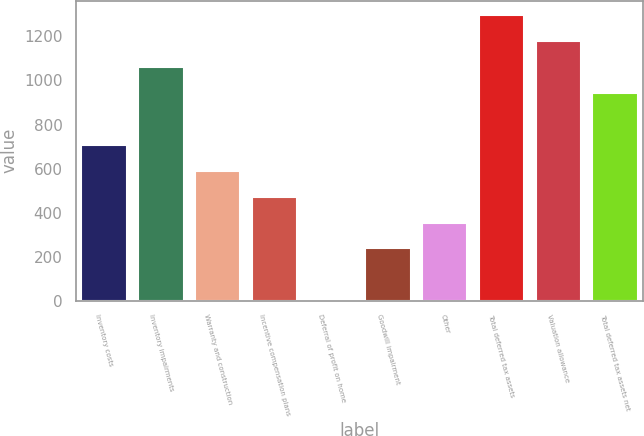Convert chart. <chart><loc_0><loc_0><loc_500><loc_500><bar_chart><fcel>Inventory costs<fcel>Inventory impairments<fcel>Warranty and construction<fcel>Incentive compensation plans<fcel>Deferral of profit on home<fcel>Goodwill impairment<fcel>Other<fcel>Total deferred tax assets<fcel>Valuation allowance<fcel>Total deferred tax assets net<nl><fcel>708.04<fcel>1061.26<fcel>590.3<fcel>472.56<fcel>1.6<fcel>237.08<fcel>354.82<fcel>1296.74<fcel>1179<fcel>943.52<nl></chart> 